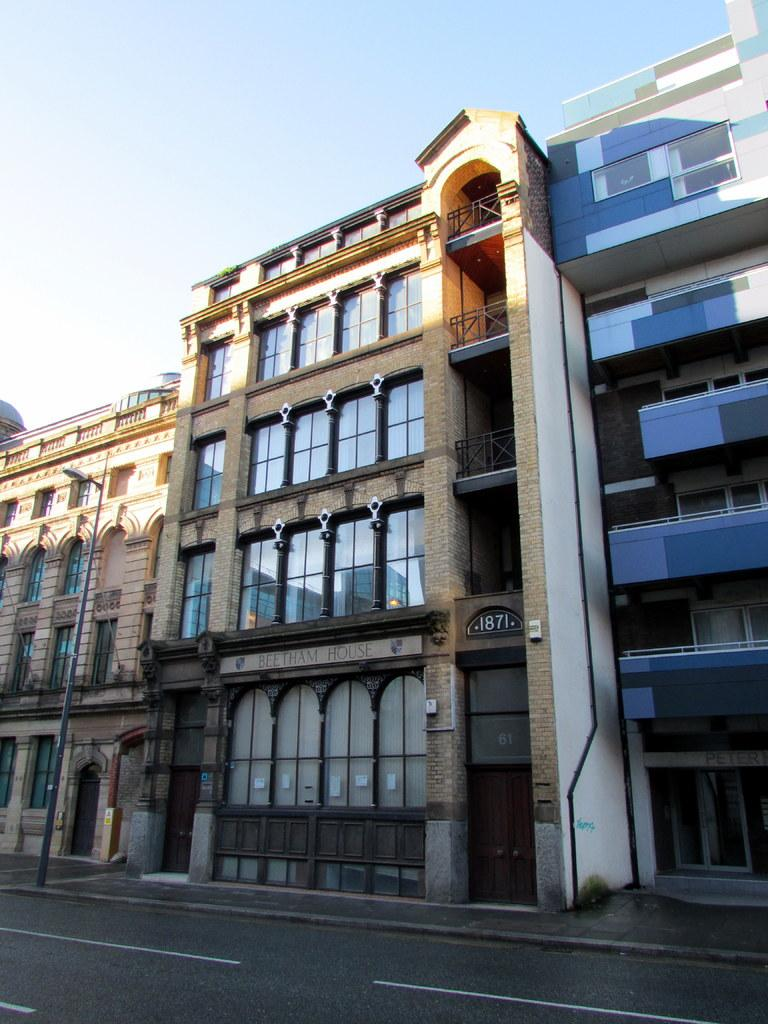What type of structures can be seen in the image? There are buildings in the image. Where is the pole located in the image? The pole is in the left corner of the image. What is in front of the pole? There is a road in front of the pole. What type of sheet is covering the buildings in the image? There is no sheet covering the buildings in the image; they are visible as they are. 